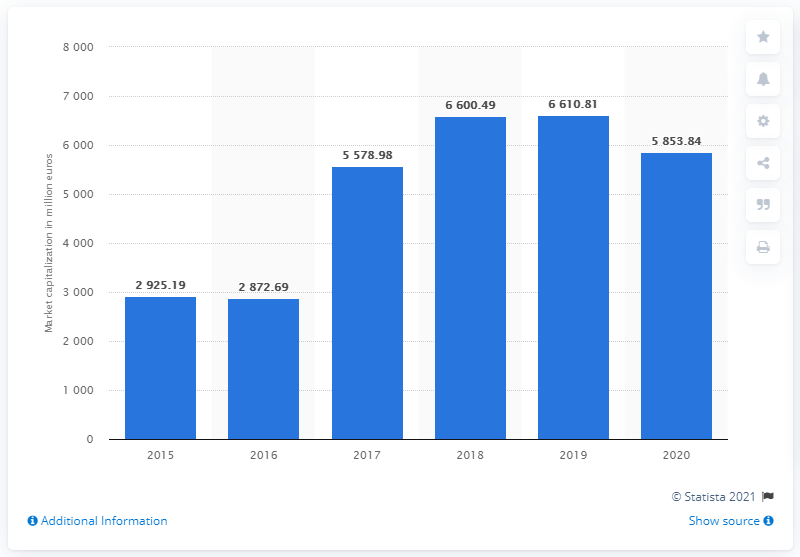Outline some significant characteristics in this image. As of December 2020, the market capitalization of companies listed on the Alternative Investment Market on the Milan Stock Exchange was 5,853.84. 